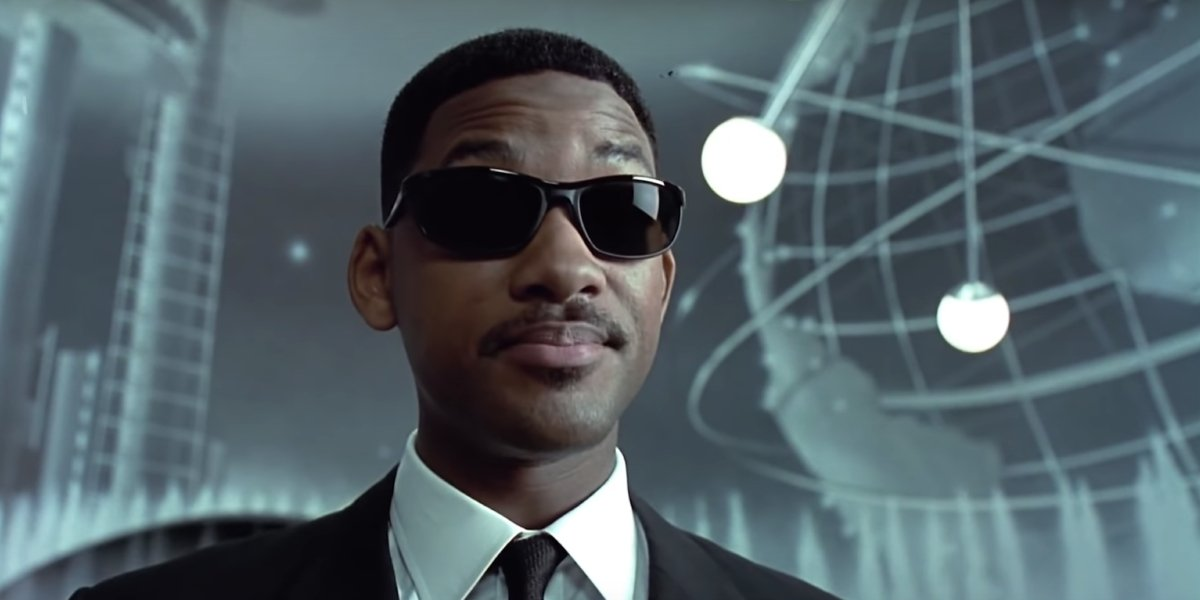What is the most intriguing element in this image? The most intriguing element in this image is the metallic globe in the background. It appears to be part of some advanced technology or an alien navigation system. This striking piece adds a layer of mystery and sci-fi intrigue to the otherwise straightforward image of a secret agent. It piques curiosity about its purpose and the kind of high-tech world the character operates in. Describe a day in the life of this character based on the image. A typical day for this secret agent likely starts early, with a rigorous workout and meticulous preparation of his black suit. He then heads to a state-of-the-art headquarters, where he's briefed on the latest interstellar threats and missions. His day involves high-speed chases, covert meetings with alien informants, and the testing of new-age gadgets. He balances field missions with strategic planning, often finding himself in the thick of action, neutralizing threats with precision. Evenings are spent in debriefings and planning for future missions, ensuring he's always one step ahead. Create a whimsical and imaginative scenario involving this character. In an unexpected twist, our secret agent encounters a magical nebula that grants him the ability to speak every language in the universe, including those of plants and animals. Suddenly, everyday objects start revealing secrets of ancient civilizations, and animals in the wild offer intelligence on planetary threats. Using these newfound abilities, he solves a centuries-old riddle that has baffled humanity, uncovering a hidden portal to a utopia where knowledge and harmony reign supreme. Along the way, he teams up with a talking tree and a wise-cracking holographic cat, adding humor and wonder to his serious demeanor. How does this character handle an unexpected alien technology malfunction? When faced with an alien technology malfunction in the heart of the city, the agent springs into action. His neuralyzer failing, he relies on his quick thinking and expertise. He rapidly assesses the device, using both human and extraterrestrial knowledge to stabilize its erratic behavior. His calm under pressure reassures the public as he works tirelessly, eventually isolating the malfunction's source and shutting it down. His resolution ensures the safety of the city and maintains the veil of secrecy surrounding extraterrestrial technology. 